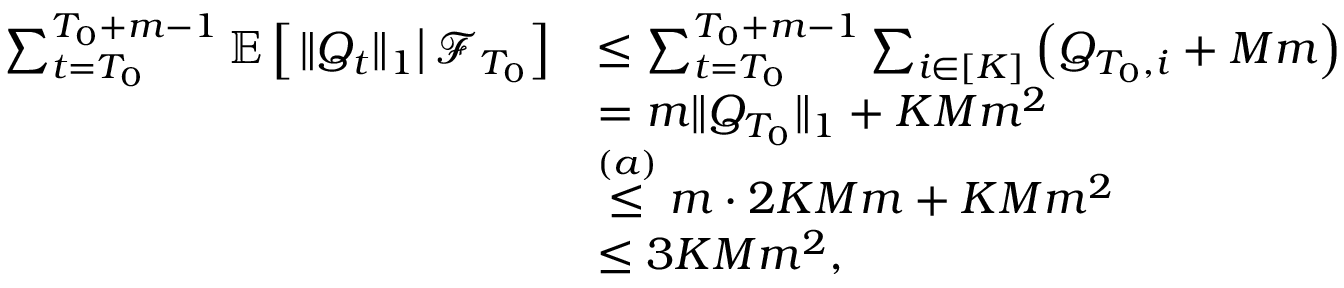Convert formula to latex. <formula><loc_0><loc_0><loc_500><loc_500>\begin{array} { r l } { \sum _ { t = T _ { 0 } } ^ { T _ { 0 } + m - 1 } \mathbb { E } \left [ \| Q _ { t } \| _ { 1 } \right | \mathcal { F } _ { T _ { 0 } } \right ] } & { \leq \sum _ { t = T _ { 0 } } ^ { T _ { 0 } + m - 1 } \sum _ { i \in [ K ] } \left ( Q _ { T _ { 0 } , i } + M m \right ) } \\ & { = m \| Q _ { T _ { 0 } } \| _ { 1 } + K M m ^ { 2 } } \\ & { \stackrel { ( a ) } \leq m \cdot 2 K M m + K M m ^ { 2 } } \\ & { \leq 3 K M m ^ { 2 } , } \end{array}</formula> 